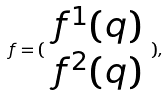Convert formula to latex. <formula><loc_0><loc_0><loc_500><loc_500>f = ( \begin{array} { c } f ^ { 1 } ( q ) \\ f ^ { 2 } ( q ) \end{array} ) ,</formula> 